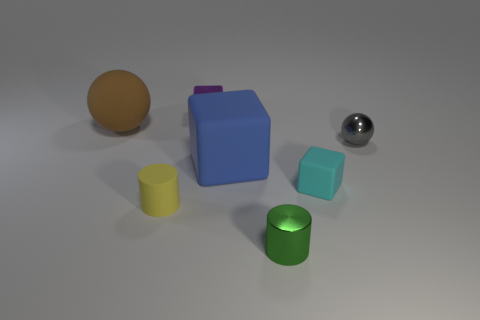What size is the purple shiny cube that is behind the small rubber cylinder? The size of the purple shiny cube positioned behind the small rubber cylinder appears to be medium compared to other objects in the image. It is larger than the cylinder and small teal cube in the foreground but smaller than the larger blue block to its side. 